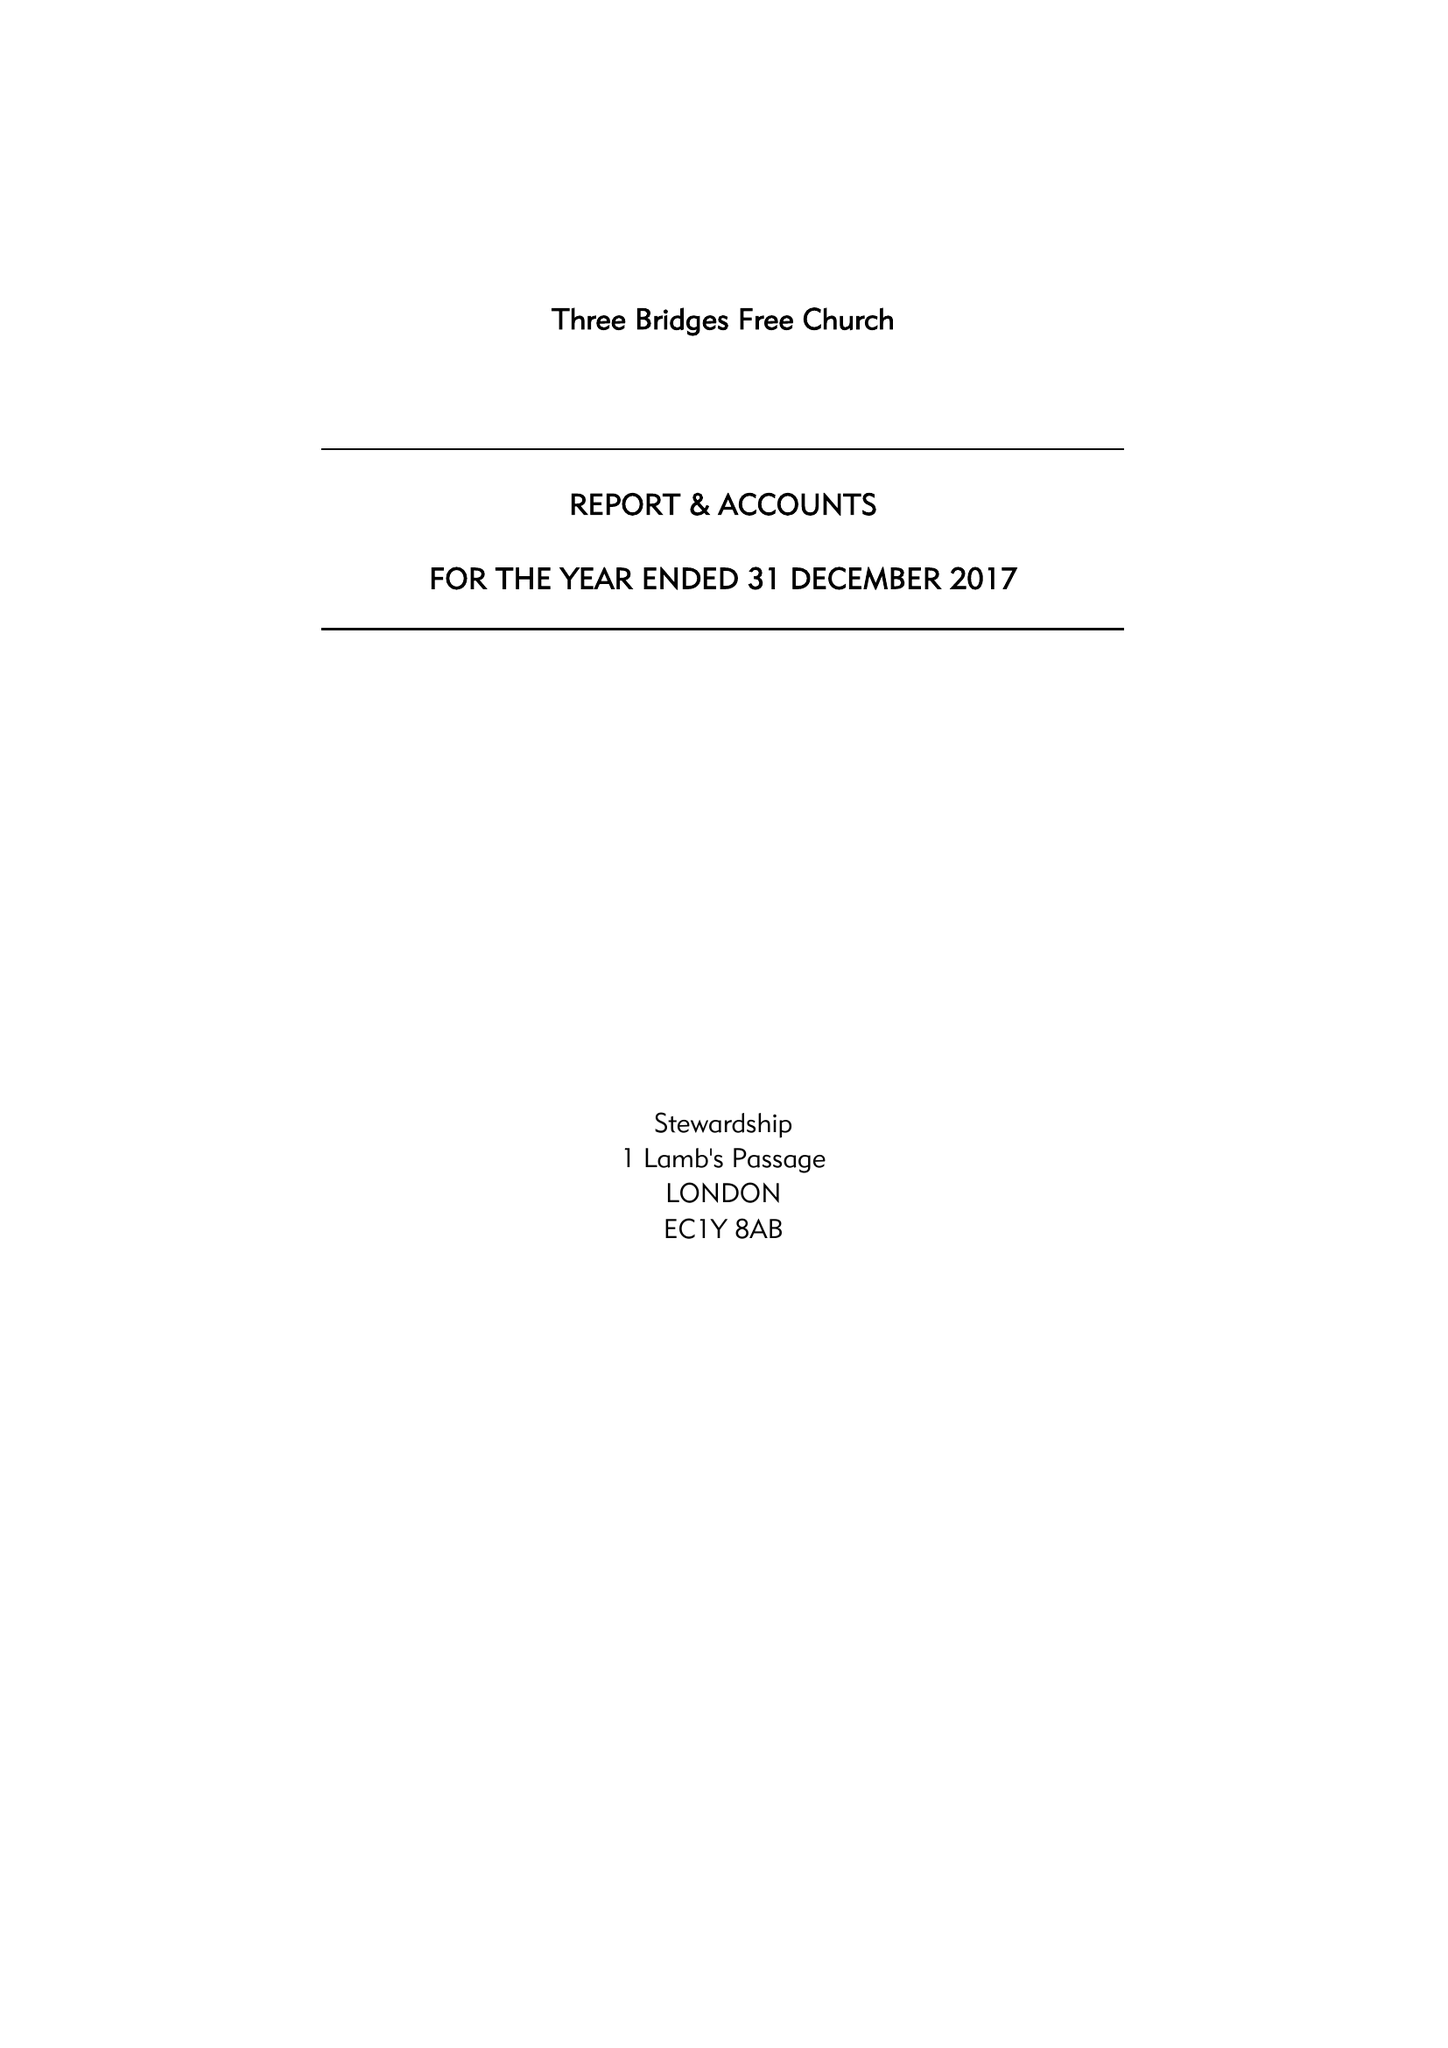What is the value for the income_annually_in_british_pounds?
Answer the question using a single word or phrase. 134629.00 